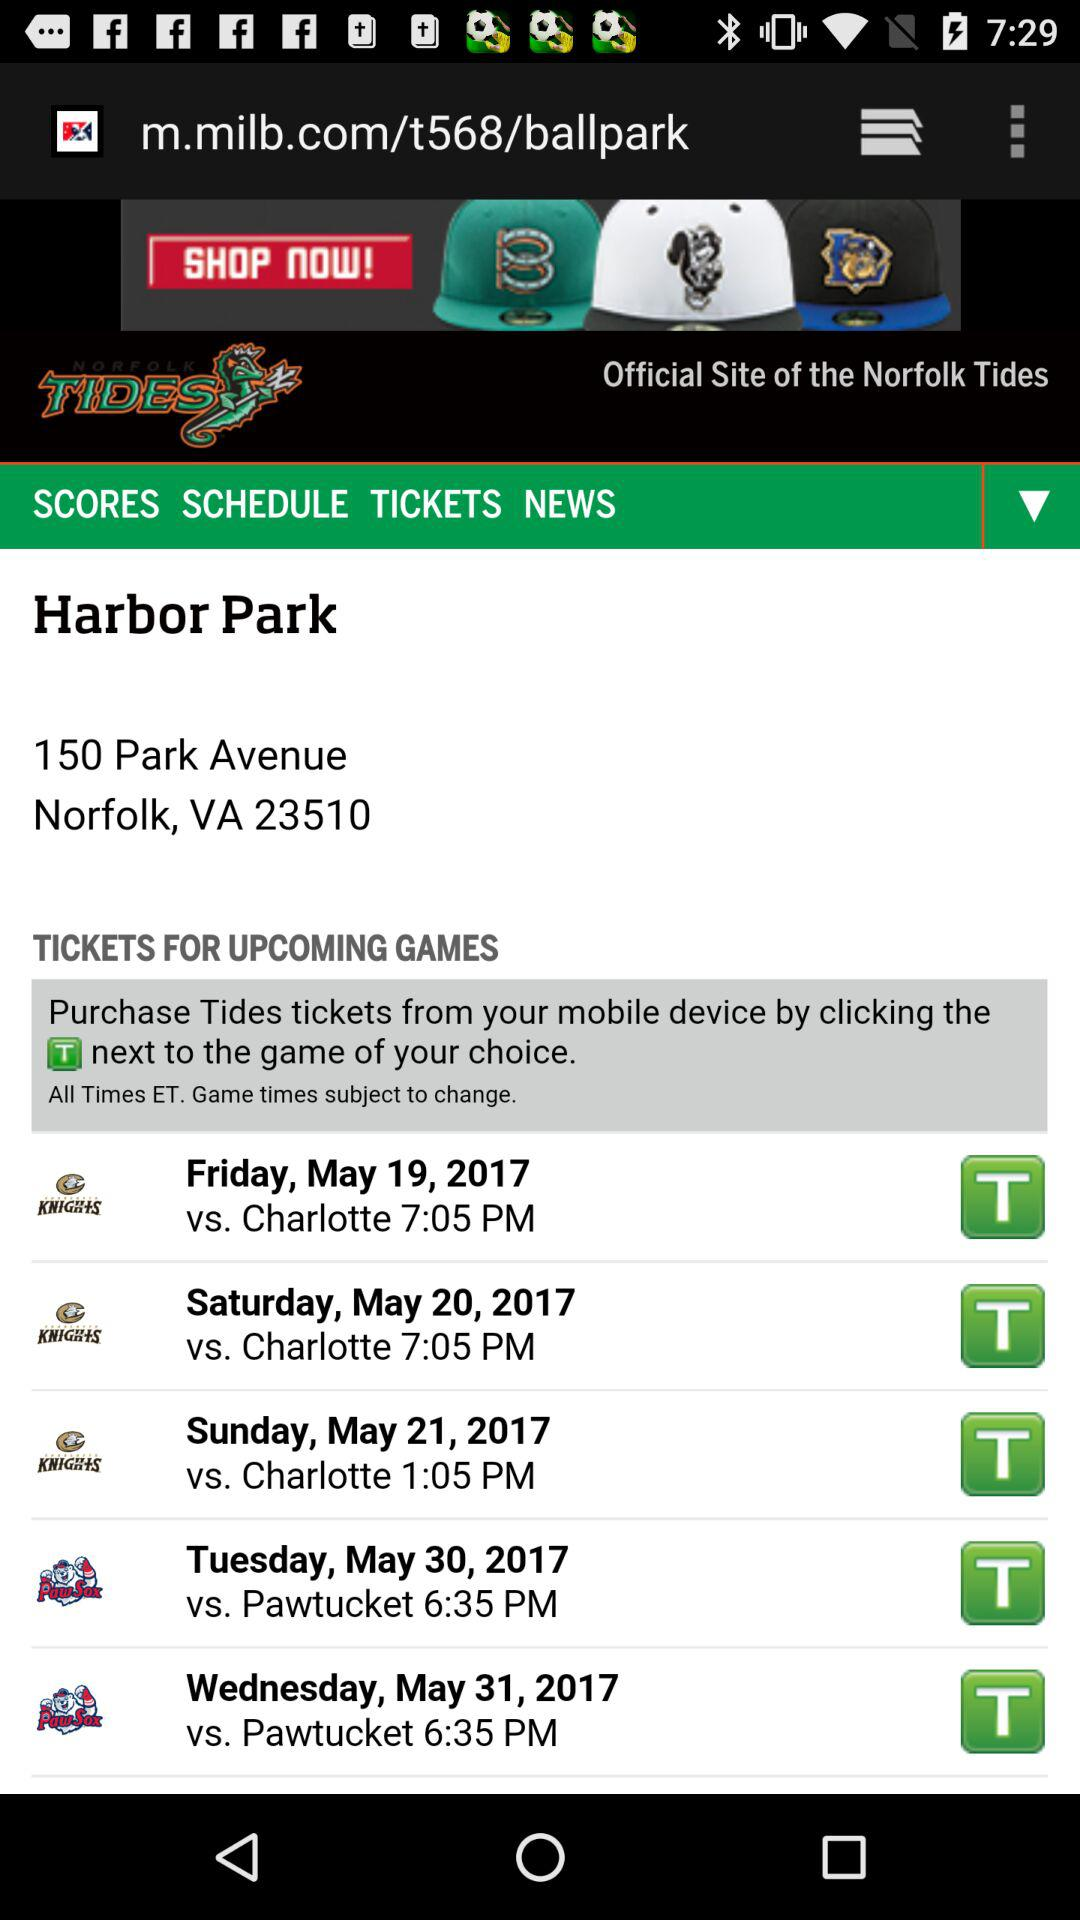What is the name of the stadium given on the screen? The name of the stadium is "Harbor Park". 